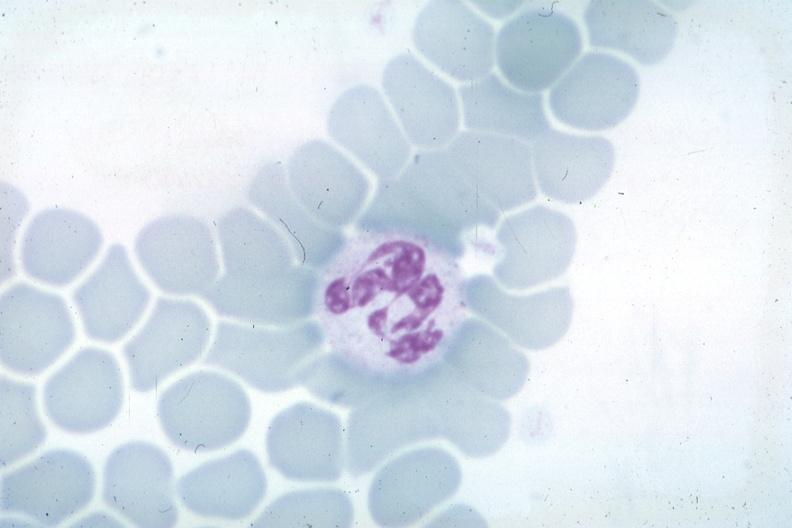what is nuclear change unknown?
Answer the question using a single word or phrase. Obvious source 